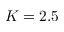<formula> <loc_0><loc_0><loc_500><loc_500>K = 2 . 5</formula> 